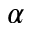Convert formula to latex. <formula><loc_0><loc_0><loc_500><loc_500>\alpha</formula> 